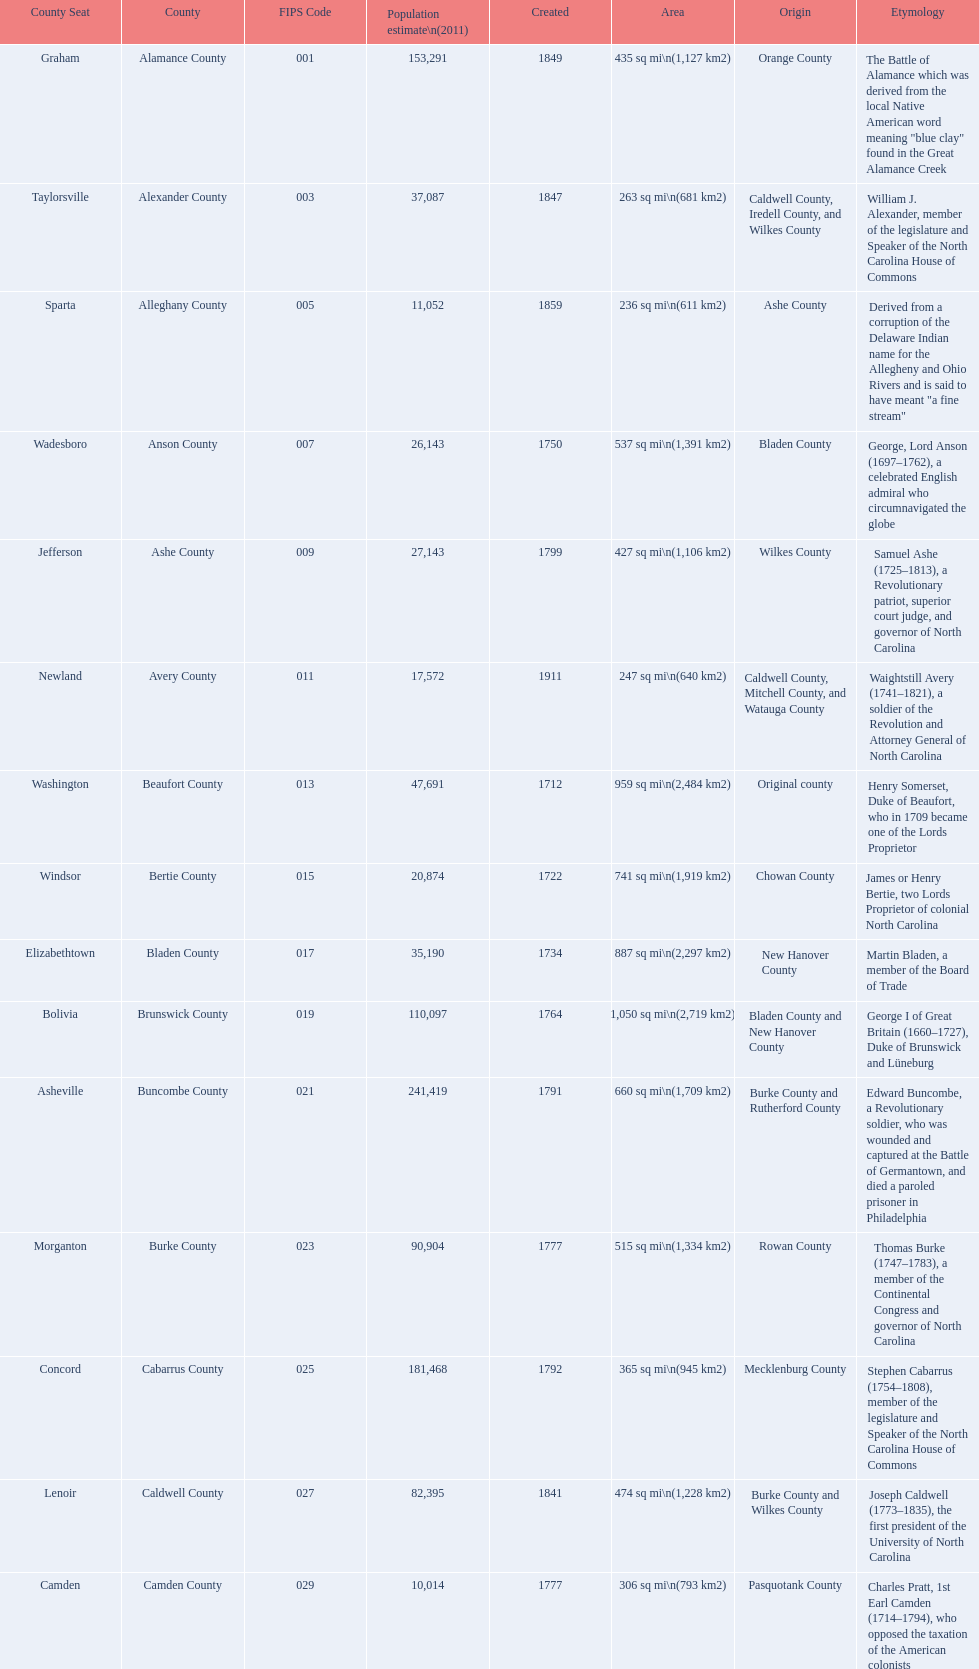Other than mecklenburg which county has the largest population? Wake County. 